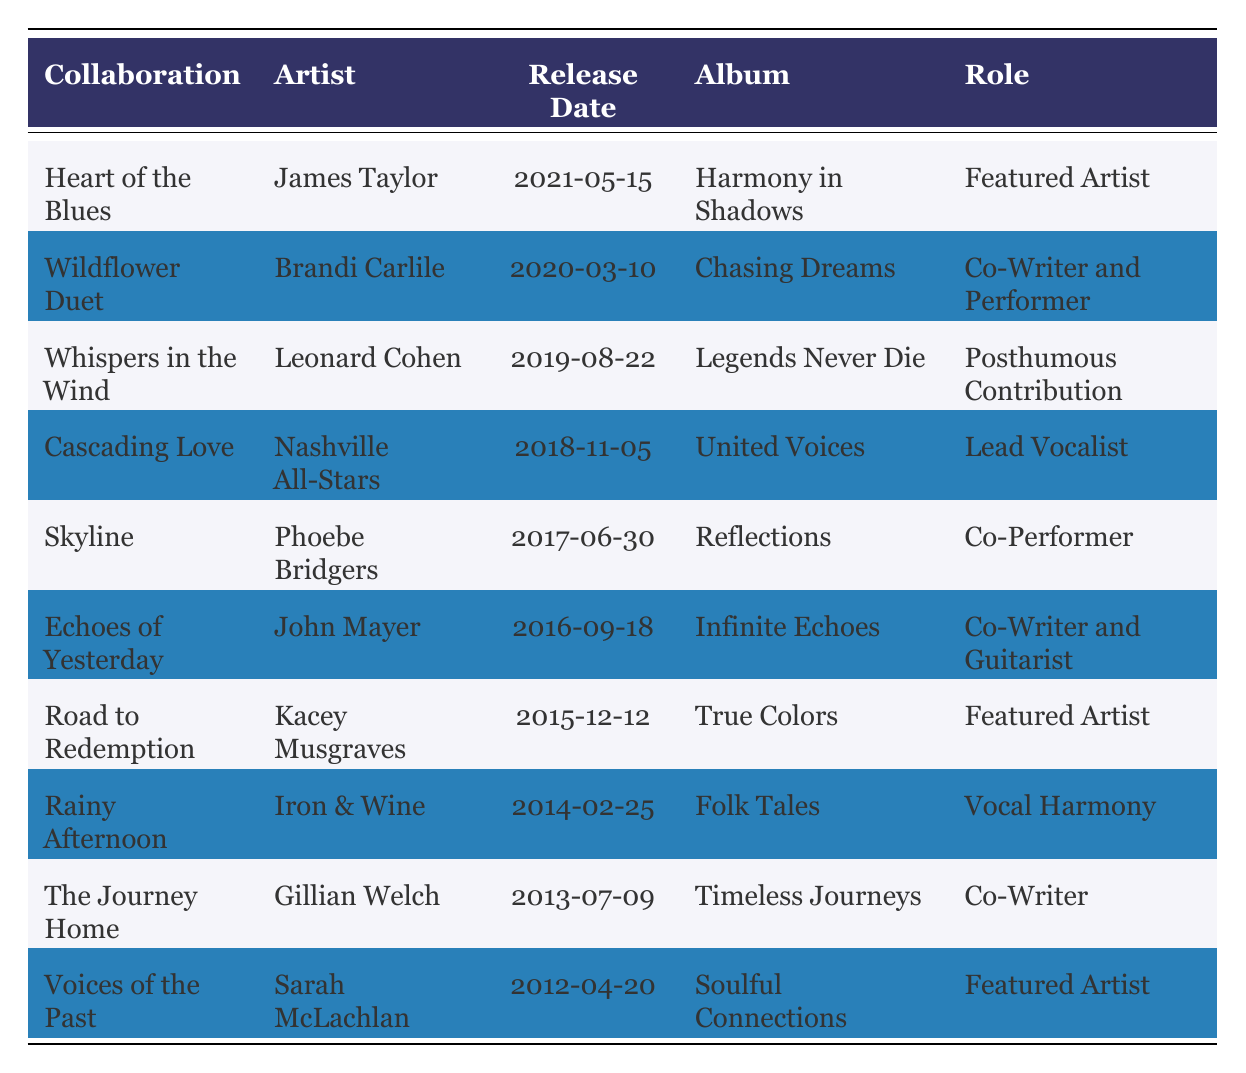What is the name of the collaboration with James Taylor? From the table, we look for the row that lists the artist James Taylor. The corresponding "Collaboration" column shows "Heart of the Blues".
Answer: Heart of the Blues Which album features "Voices of the Past"? By checking the row for the collaboration "Voices of the Past", the associated album listed in the table is "Soulful Connections".
Answer: Soulful Connections Did you collaborate with Kacey Musgraves? To answer this, we look for any row with Kacey Musgraves as the artist. The table shows "Road to Redemption" as a collaboration, confirming the artist collaborated.
Answer: Yes How many collaborations are listed that feature you as a "Featured Artist"? We can filter the table to find each collaboration where the "Role" column states "Featured Artist". There are three instances: "Heart of the Blues", "Road to Redemption", and "Voices of the Past". Therefore, the count is 3.
Answer: 3 Which collaboration has the earliest release date? To ascertain the earliest release date, we can compare the "Release Date" column values. The earliest date is "2012-04-20" for "Voices of the Past".
Answer: Voices of the Past What role did you play in the collaboration "Cascading Love"? We check the row for "Cascading Love" and find the role listed is "Lead Vocalist".
Answer: Lead Vocalist Is "Whispers in the Wind" a posthumous contribution? By finding the row for "Whispers in the Wind", it indicates "Posthumous Contribution" in the "Role" column, confirming this fact.
Answer: Yes Who is the artist for the collaboration that was released in 2019? Searching through the table for the release year of 2019, we find "Whispers in the Wind" associated with Leonard Cohen.
Answer: Leonard Cohen How many collaborations were released after 2015? We can count the entries after the year 2015. The rows for the releases from 2016 to 2021 are six collaborations: "Echoes of Yesterday", "Road to Redemption", "Skyline", "Cascading Love", "Wildflower Duet", and "Heart of the Blues".
Answer: 6 